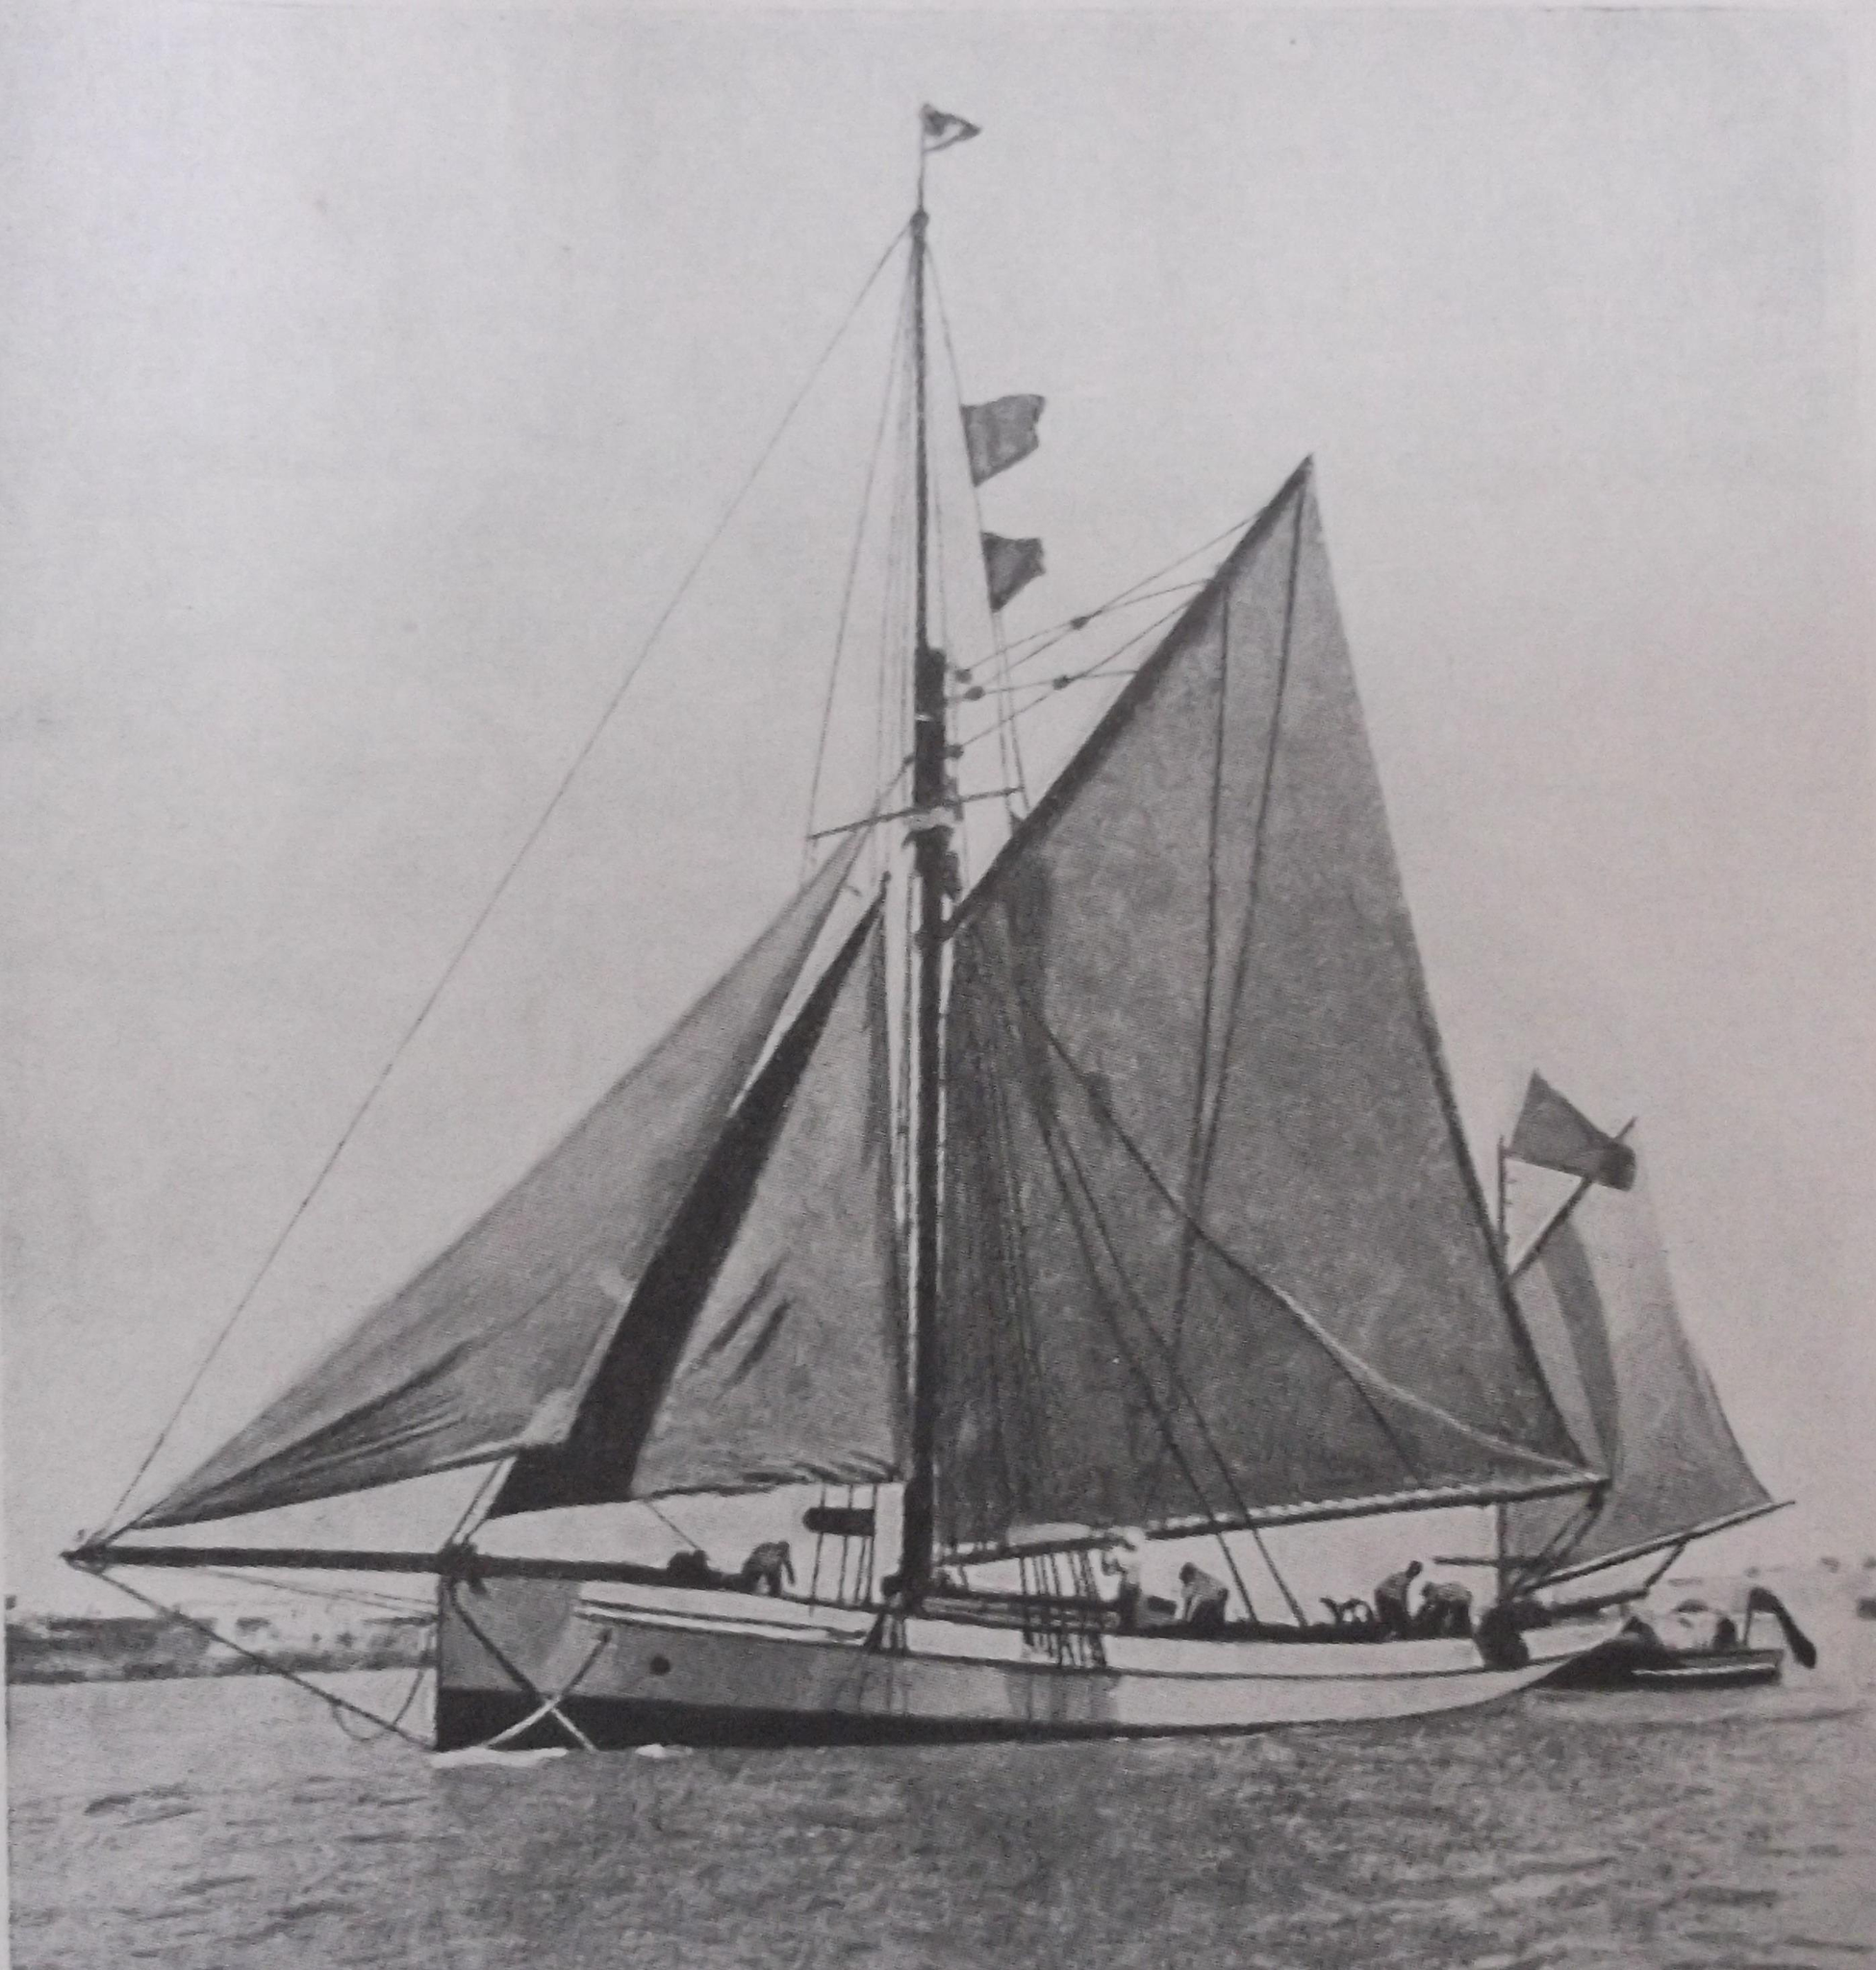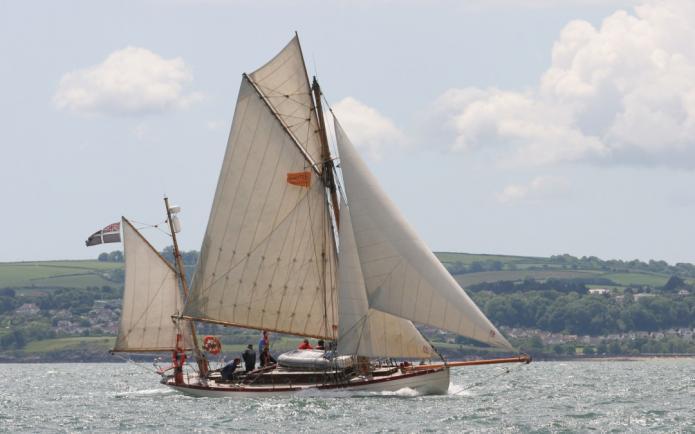The first image is the image on the left, the second image is the image on the right. Evaluate the accuracy of this statement regarding the images: "Two boats are sailing.". Is it true? Answer yes or no. Yes. 